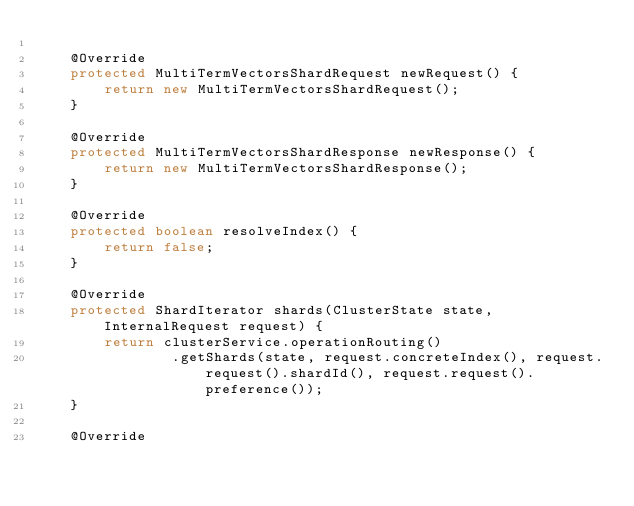Convert code to text. <code><loc_0><loc_0><loc_500><loc_500><_Java_>
    @Override
    protected MultiTermVectorsShardRequest newRequest() {
        return new MultiTermVectorsShardRequest();
    }

    @Override
    protected MultiTermVectorsShardResponse newResponse() {
        return new MultiTermVectorsShardResponse();
    }

    @Override
    protected boolean resolveIndex() {
        return false;
    }

    @Override
    protected ShardIterator shards(ClusterState state, InternalRequest request) {
        return clusterService.operationRouting()
                .getShards(state, request.concreteIndex(), request.request().shardId(), request.request().preference());
    }

    @Override</code> 